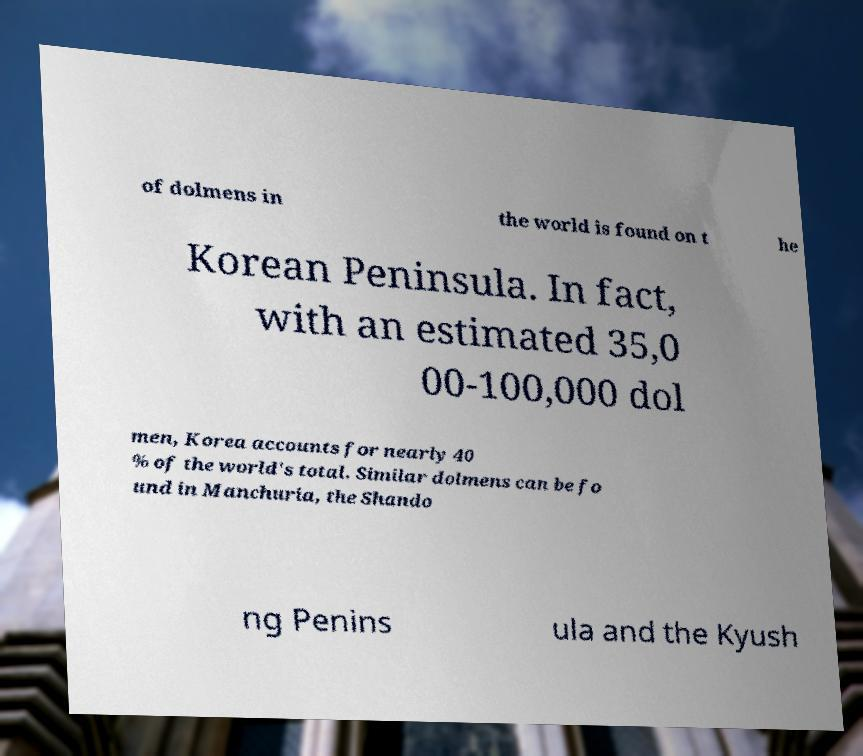Please identify and transcribe the text found in this image. of dolmens in the world is found on t he Korean Peninsula. In fact, with an estimated 35,0 00-100,000 dol men, Korea accounts for nearly 40 % of the world's total. Similar dolmens can be fo und in Manchuria, the Shando ng Penins ula and the Kyush 